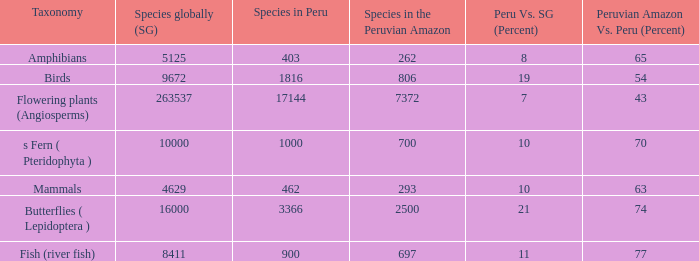What is the species with a 63 percent distribution in the peruvian amazon compared to the whole of peru? 4629.0. 